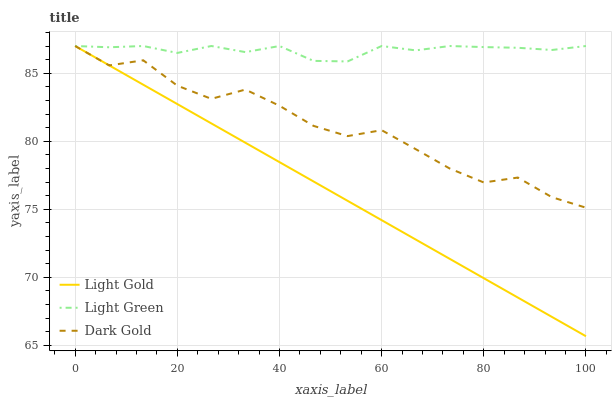Does Light Gold have the minimum area under the curve?
Answer yes or no. Yes. Does Light Green have the maximum area under the curve?
Answer yes or no. Yes. Does Dark Gold have the minimum area under the curve?
Answer yes or no. No. Does Dark Gold have the maximum area under the curve?
Answer yes or no. No. Is Light Gold the smoothest?
Answer yes or no. Yes. Is Dark Gold the roughest?
Answer yes or no. Yes. Is Light Green the smoothest?
Answer yes or no. No. Is Light Green the roughest?
Answer yes or no. No. Does Dark Gold have the lowest value?
Answer yes or no. No. 